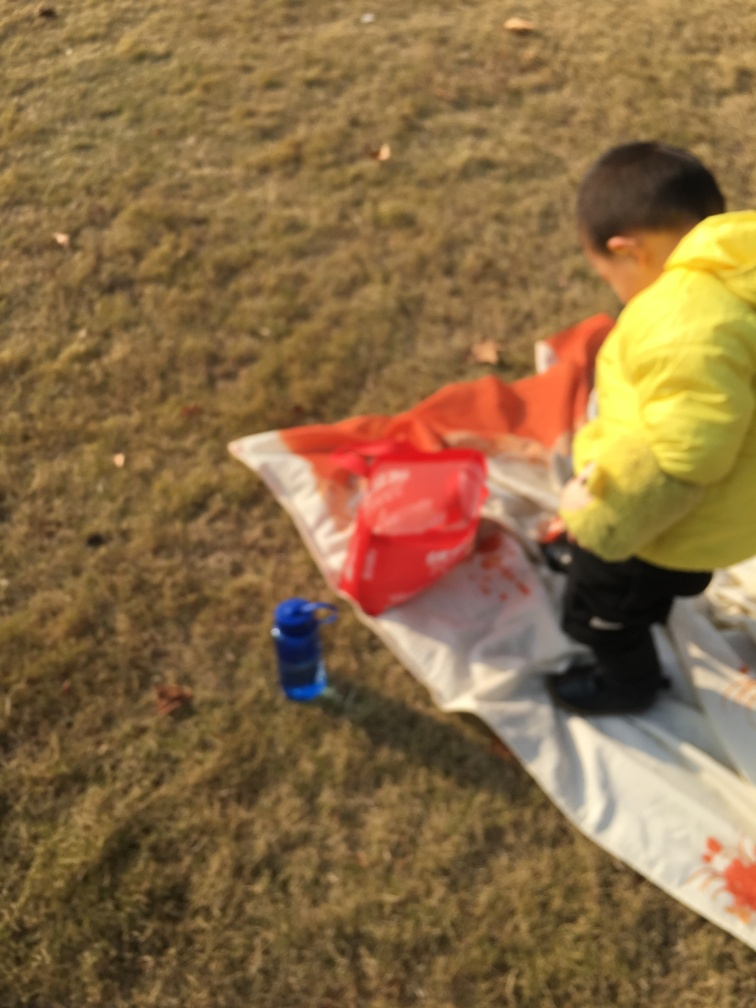What activities might the child be engaged in based on the items around? The child appears to be outdoors, possibly in a park or a garden. The presence of a plastic bag and a water bottle suggests the child might be having a picnic or a snack outside. Is there anything interesting about the setting? Although the image is blurred, the outdoor setting with grass and a tarp laid out indicates a leisurely day in a casual and natural environment, which may suggest a relaxed atmosphere. 